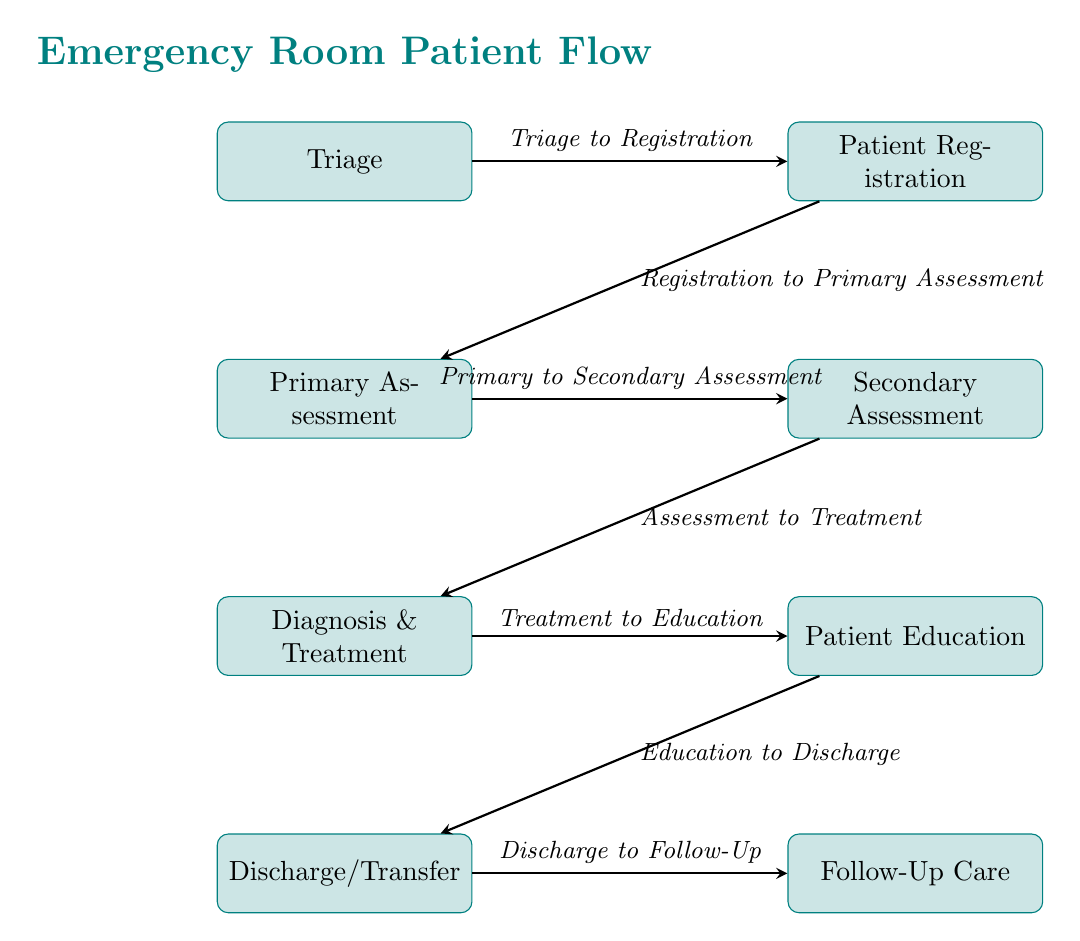What is the first step in the emergency room process? The first node in the diagram is labeled "Triage," indicating that this is the initial step patients undergo upon arrival in the emergency room.
Answer: Triage How many main steps are depicted in the diagram? By counting the nodes in the diagram from "Triage" through to "Follow-Up Care," we see there are a total of seven main steps in the emergency room patient flow.
Answer: Seven What follows the Primary Assessment step? According to the diagram, the step that follows "Primary Assessment" is labeled "Secondary Assessment," which is the next action taken in the patient flow.
Answer: Secondary Assessment What is the relationship between Diagnosis and Patient Education? The diagram shows an arrow flowing from "Diagnosis" to "Patient Education," indicating that after a diagnosis is made, the subsequent step involves educating the patient about their condition and treatment.
Answer: Diagnosis to Patient Education Which step comes just before Discharge/Transfer? The step that comes just before "Discharge/Transfer" is "Patient Education," as indicated by the direct arrow linking these two nodes in the patient flow process.
Answer: Patient Education How many arrows indicate the flow from one step to another? A total of six arrows are present in the diagram, each representing the directional flow from one procedural step to the next in the emergency room process.
Answer: Six What is the last step in the emergency room patient flow? The final node in the diagram is "Follow-Up Care," indicating that this is the concluding step in the emergency room patient flow, after discharge or transfer.
Answer: Follow-Up Care What step is indicated to occur after Registration? The flow from "Registration" leads directly to "Primary Assessment," as depicted in the diagram, signifying that these are consecutive steps in the emergency room process.
Answer: Primary Assessment What process follows the Secondary Assessment? The step that follows "Secondary Assessment" according to the diagram is "Diagnosis & Treatment," which indicates the next phase patients enter after the secondary evaluation.
Answer: Diagnosis & Treatment 